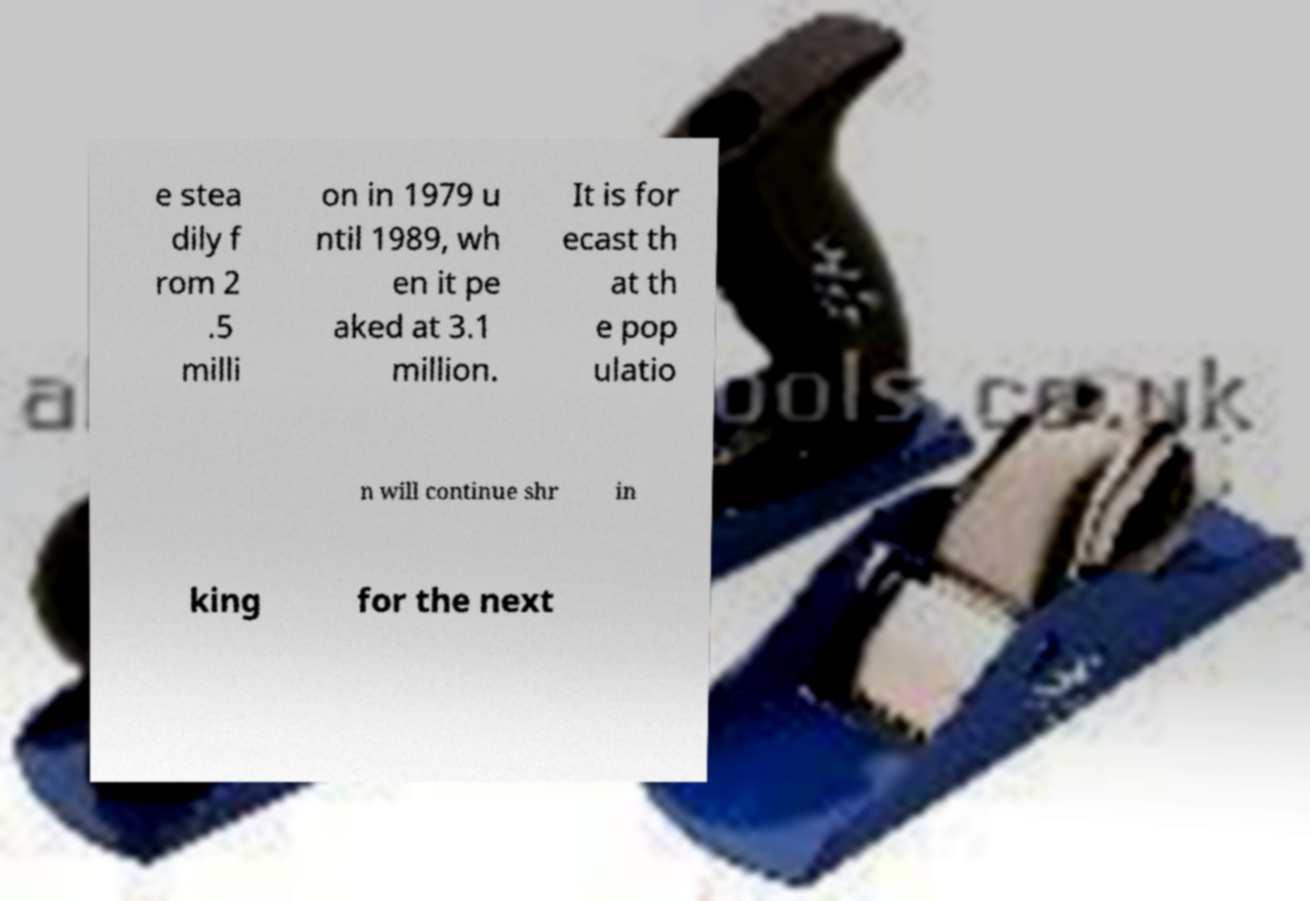Please read and relay the text visible in this image. What does it say? e stea dily f rom 2 .5 milli on in 1979 u ntil 1989, wh en it pe aked at 3.1 million. It is for ecast th at th e pop ulatio n will continue shr in king for the next 